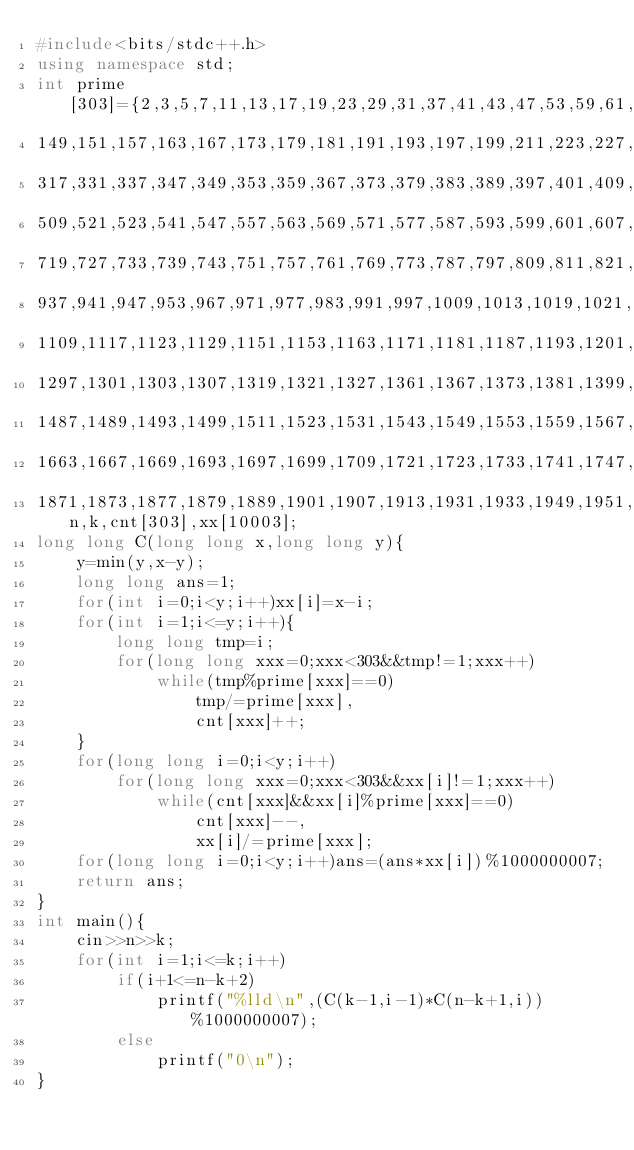<code> <loc_0><loc_0><loc_500><loc_500><_C++_>#include<bits/stdc++.h>
using namespace std;
int prime[303]={2,3,5,7,11,13,17,19,23,29,31,37,41,43,47,53,59,61,67,71,73,79,83,89,97,101,103,107,109,113,127,131,137,139,
149,151,157,163,167,173,179,181,191,193,197,199,211,223,227,229,233,239,241,251,257,263,269,271,277,281,283,293,307,311,313,
317,331,337,347,349,353,359,367,373,379,383,389,397,401,409,419,421,431,433,439,443,449,457,461,463,467,479,487,491,499,503,
509,521,523,541,547,557,563,569,571,577,587,593,599,601,607,613,617,619,631,641,643,647,653,659,661,673,677,683,691,701,709,
719,727,733,739,743,751,757,761,769,773,787,797,809,811,821,823,827,829,839,853,857,859,863,877,881,883,887,907,911,919,929,
937,941,947,953,967,971,977,983,991,997,1009,1013,1019,1021,1031,1033,1039,1049,1051,1061,1063,1069,1087,1091,1093,1097,1103,
1109,1117,1123,1129,1151,1153,1163,1171,1181,1187,1193,1201,1213,1217,1223,1229,1231,1237,1249,1259,1277,1279,1283,1289,1291,
1297,1301,1303,1307,1319,1321,1327,1361,1367,1373,1381,1399,1409,1423,1427,1429,1433,1439,1447,1451,1453,1459,1471,1481,1483,
1487,1489,1493,1499,1511,1523,1531,1543,1549,1553,1559,1567,1571,1579,1583,1597,1601,1607,1609,1613,1619,1621,1627,1637,1657,
1663,1667,1669,1693,1697,1699,1709,1721,1723,1733,1741,1747,1753,1759,1777,1783,1787,1789,1801,1811,1823,1831,1847,1861,1867,
1871,1873,1877,1879,1889,1901,1907,1913,1931,1933,1949,1951,1973,1979,1987,1993,1997,1999},n,k,cnt[303],xx[10003];
long long C(long long x,long long y){
	y=min(y,x-y);
	long long ans=1;
	for(int i=0;i<y;i++)xx[i]=x-i;
	for(int i=1;i<=y;i++){
		long long tmp=i;
		for(long long xxx=0;xxx<303&&tmp!=1;xxx++)
			while(tmp%prime[xxx]==0)
				tmp/=prime[xxx],
				cnt[xxx]++;
	}
	for(long long i=0;i<y;i++)
		for(long long xxx=0;xxx<303&&xx[i]!=1;xxx++)
			while(cnt[xxx]&&xx[i]%prime[xxx]==0)
				cnt[xxx]--,
				xx[i]/=prime[xxx];
	for(long long i=0;i<y;i++)ans=(ans*xx[i])%1000000007;
	return ans;
}
int main(){
	cin>>n>>k;
	for(int i=1;i<=k;i++)
		if(i+1<=n-k+2)
			printf("%lld\n",(C(k-1,i-1)*C(n-k+1,i))%1000000007);
		else
			printf("0\n");
}</code> 